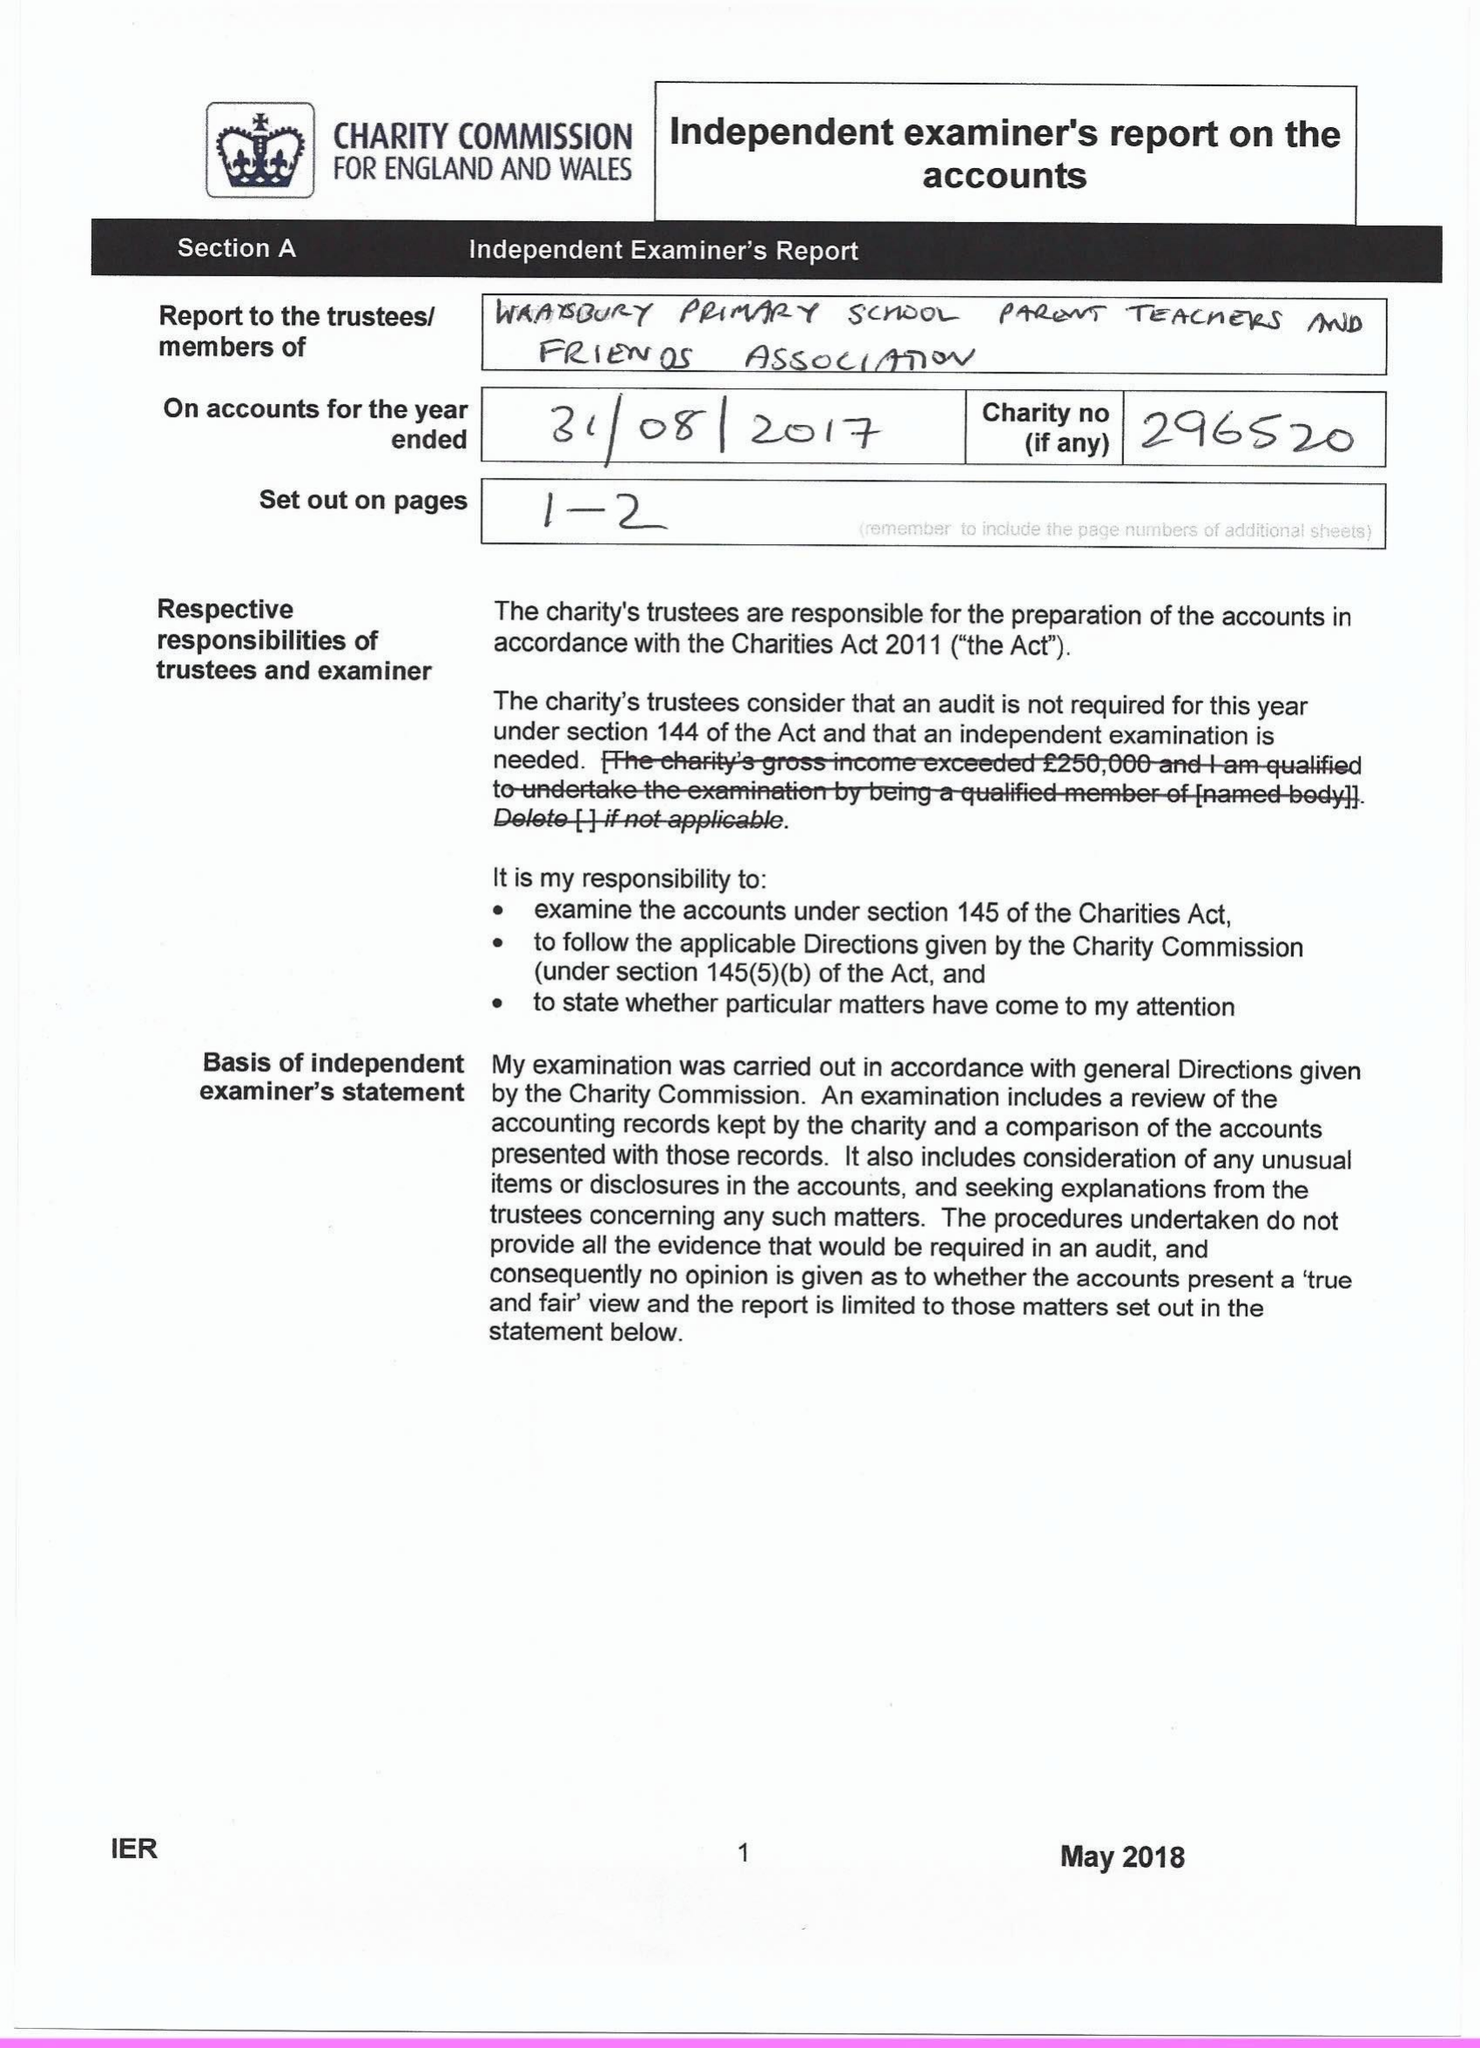What is the value for the income_annually_in_british_pounds?
Answer the question using a single word or phrase. 55043.00 